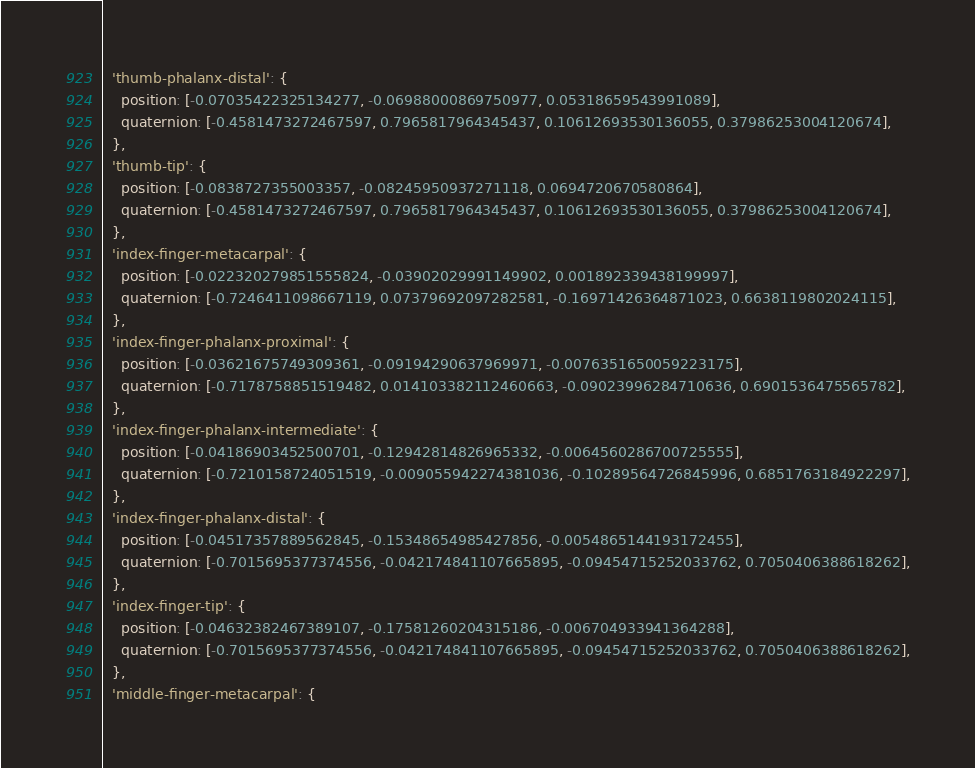<code> <loc_0><loc_0><loc_500><loc_500><_TypeScript_>  'thumb-phalanx-distal': {
    position: [-0.07035422325134277, -0.06988000869750977, 0.05318659543991089],
    quaternion: [-0.4581473272467597, 0.7965817964345437, 0.10612693530136055, 0.37986253004120674],
  },
  'thumb-tip': {
    position: [-0.0838727355003357, -0.08245950937271118, 0.0694720670580864],
    quaternion: [-0.4581473272467597, 0.7965817964345437, 0.10612693530136055, 0.37986253004120674],
  },
  'index-finger-metacarpal': {
    position: [-0.022320279851555824, -0.03902029991149902, 0.001892339438199997],
    quaternion: [-0.7246411098667119, 0.07379692097282581, -0.16971426364871023, 0.6638119802024115],
  },
  'index-finger-phalanx-proximal': {
    position: [-0.03621675749309361, -0.09194290637969971, -0.0076351650059223175],
    quaternion: [-0.7178758851519482, 0.014103382112460663, -0.09023996284710636, 0.6901536475565782],
  },
  'index-finger-phalanx-intermediate': {
    position: [-0.04186903452500701, -0.12942814826965332, -0.0064560286700725555],
    quaternion: [-0.7210158724051519, -0.009055942274381036, -0.10289564726845996, 0.6851763184922297],
  },
  'index-finger-phalanx-distal': {
    position: [-0.04517357889562845, -0.15348654985427856, -0.0054865144193172455],
    quaternion: [-0.7015695377374556, -0.042174841107665895, -0.09454715252033762, 0.7050406388618262],
  },
  'index-finger-tip': {
    position: [-0.04632382467389107, -0.17581260204315186, -0.006704933941364288],
    quaternion: [-0.7015695377374556, -0.042174841107665895, -0.09454715252033762, 0.7050406388618262],
  },
  'middle-finger-metacarpal': {</code> 